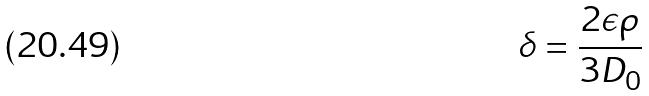Convert formula to latex. <formula><loc_0><loc_0><loc_500><loc_500>\delta = \frac { 2 \epsilon \rho } { 3 D _ { 0 } }</formula> 